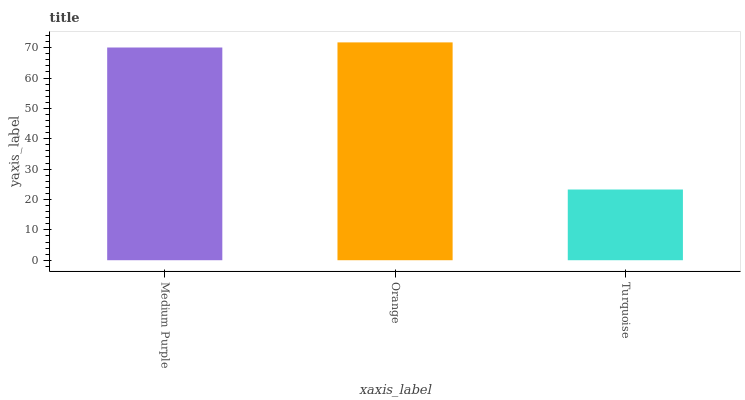Is Turquoise the minimum?
Answer yes or no. Yes. Is Orange the maximum?
Answer yes or no. Yes. Is Orange the minimum?
Answer yes or no. No. Is Turquoise the maximum?
Answer yes or no. No. Is Orange greater than Turquoise?
Answer yes or no. Yes. Is Turquoise less than Orange?
Answer yes or no. Yes. Is Turquoise greater than Orange?
Answer yes or no. No. Is Orange less than Turquoise?
Answer yes or no. No. Is Medium Purple the high median?
Answer yes or no. Yes. Is Medium Purple the low median?
Answer yes or no. Yes. Is Turquoise the high median?
Answer yes or no. No. Is Turquoise the low median?
Answer yes or no. No. 